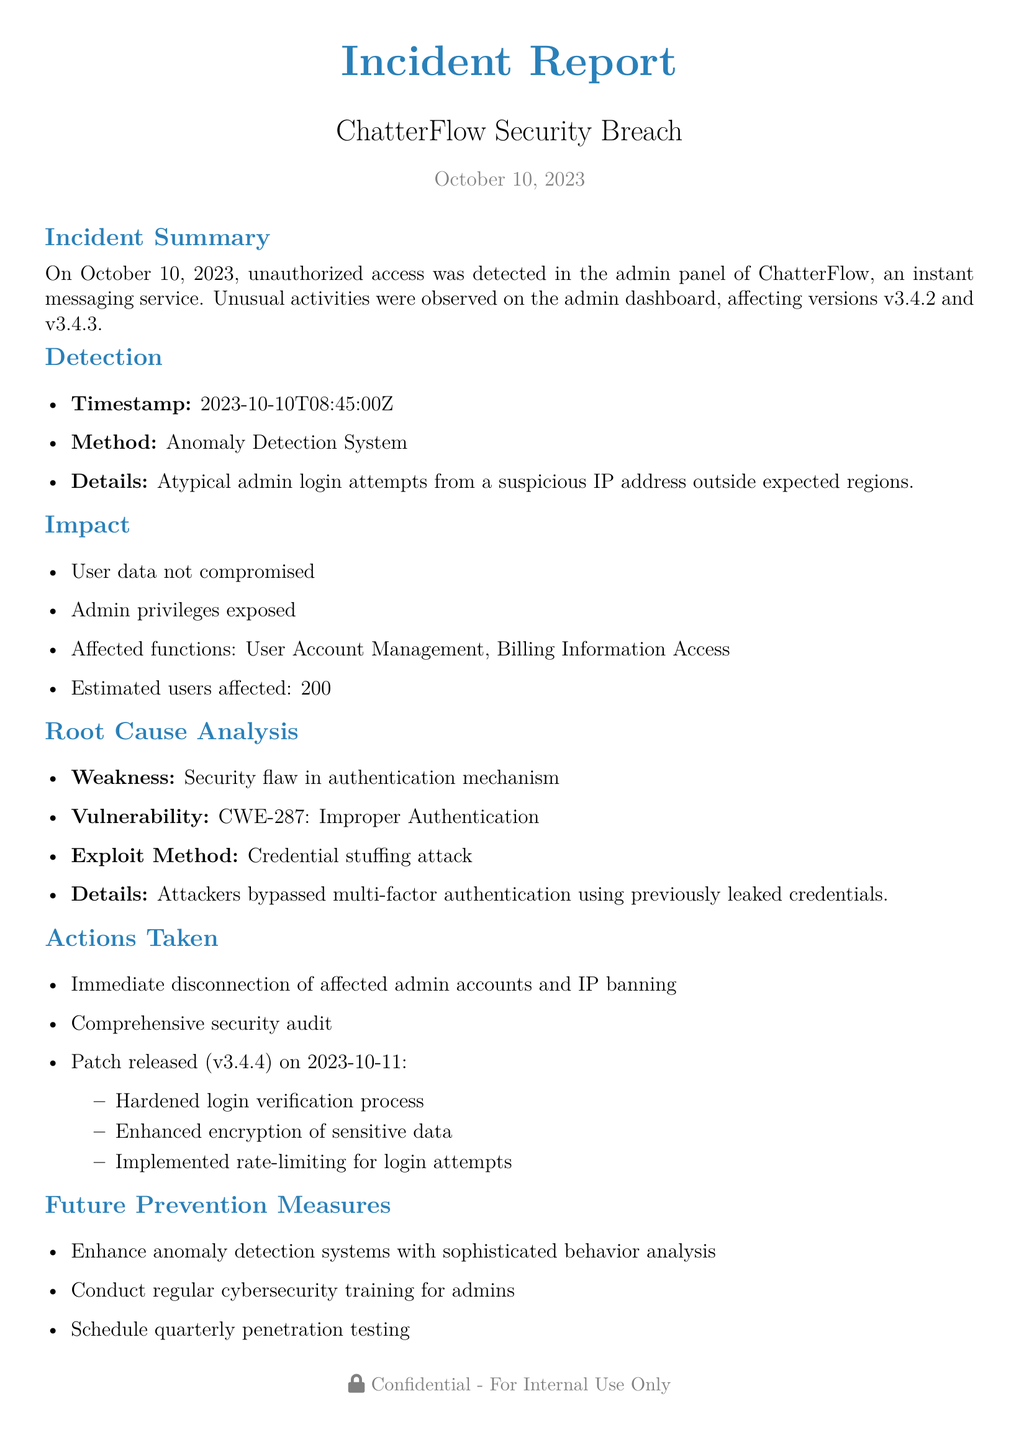What date was the incident reported? The document states that the incident was reported on October 10, 2023.
Answer: October 10, 2023 How many users were estimated to be affected by the incident? The document mentions that approximately 200 users were affected.
Answer: 200 What was the method of detection used for the incident? The document specifies that the Anomaly Detection System was used to detect the unauthorized access.
Answer: Anomaly Detection System What was the vulnerability identified in the incident report? The report states the vulnerability to be CWE-287: Improper Authentication.
Answer: CWE-287: Improper Authentication What patch version was released after the incident? The document indicates that patch version v3.4.4 was released following the findings of the incident.
Answer: v3.4.4 What action was taken regarding affected admin accounts? According to the document, affected admin accounts were immediately disconnected and the IPs were banned.
Answer: Disconnection of affected admin accounts and IP banning What is one of the future prevention measures mentioned in the report? The report describes scheduling quarterly penetration testing as one of the future prevention measures.
Answer: Quarterly penetration testing What type of attack was used to exploit the system? The report identifies the exploit method as a credential stuffing attack.
Answer: Credential stuffing attack What function was affected concerning billing information? The affected function regarding billing information is specified as Billing Information Access.
Answer: Billing Information Access 